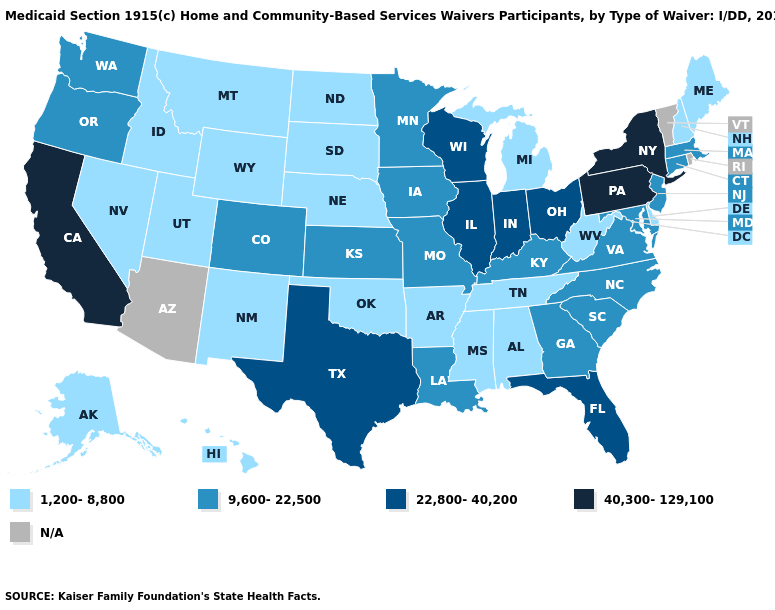Does Arkansas have the lowest value in the South?
Quick response, please. Yes. Which states have the highest value in the USA?
Short answer required. California, New York, Pennsylvania. What is the lowest value in states that border Kansas?
Concise answer only. 1,200-8,800. Is the legend a continuous bar?
Concise answer only. No. What is the highest value in states that border Arkansas?
Write a very short answer. 22,800-40,200. What is the value of Oklahoma?
Concise answer only. 1,200-8,800. What is the lowest value in the USA?
Short answer required. 1,200-8,800. Name the states that have a value in the range 22,800-40,200?
Answer briefly. Florida, Illinois, Indiana, Ohio, Texas, Wisconsin. What is the value of Michigan?
Keep it brief. 1,200-8,800. Name the states that have a value in the range 1,200-8,800?
Answer briefly. Alabama, Alaska, Arkansas, Delaware, Hawaii, Idaho, Maine, Michigan, Mississippi, Montana, Nebraska, Nevada, New Hampshire, New Mexico, North Dakota, Oklahoma, South Dakota, Tennessee, Utah, West Virginia, Wyoming. Which states have the highest value in the USA?
Keep it brief. California, New York, Pennsylvania. Is the legend a continuous bar?
Quick response, please. No. What is the highest value in states that border Rhode Island?
Quick response, please. 9,600-22,500. 